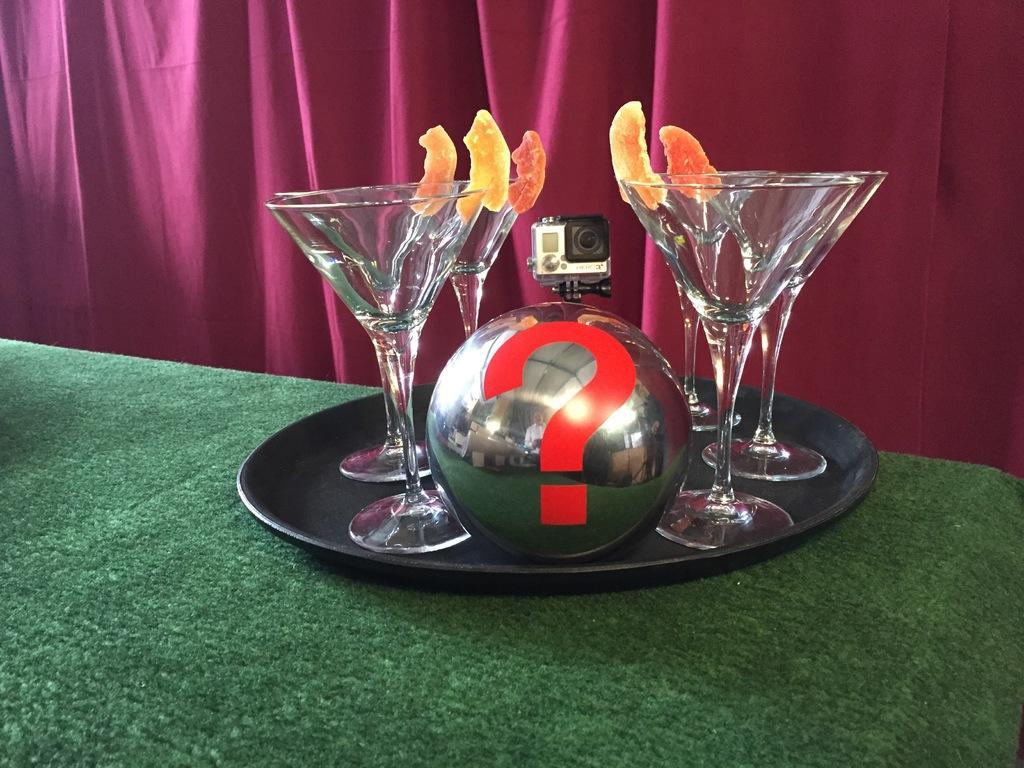In one or two sentences, can you explain what this image depicts? In this image i can see few glasses, a camera, a ball in a plate on a table, at the back ground i can see a curtain. 